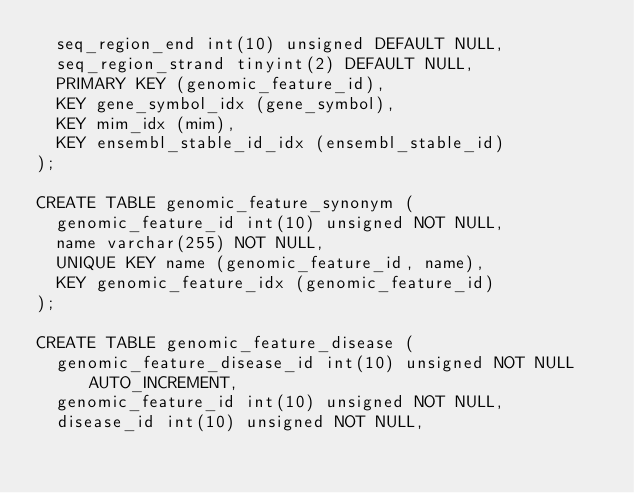Convert code to text. <code><loc_0><loc_0><loc_500><loc_500><_SQL_>  seq_region_end int(10) unsigned DEFAULT NULL,
  seq_region_strand tinyint(2) DEFAULT NULL,
  PRIMARY KEY (genomic_feature_id),
  KEY gene_symbol_idx (gene_symbol),
  KEY mim_idx (mim),
  KEY ensembl_stable_id_idx (ensembl_stable_id)
);

CREATE TABLE genomic_feature_synonym (
  genomic_feature_id int(10) unsigned NOT NULL,
  name varchar(255) NOT NULL,
  UNIQUE KEY name (genomic_feature_id, name),
  KEY genomic_feature_idx (genomic_feature_id)
);

CREATE TABLE genomic_feature_disease (
  genomic_feature_disease_id int(10) unsigned NOT NULL AUTO_INCREMENT,
  genomic_feature_id int(10) unsigned NOT NULL,
  disease_id int(10) unsigned NOT NULL,</code> 